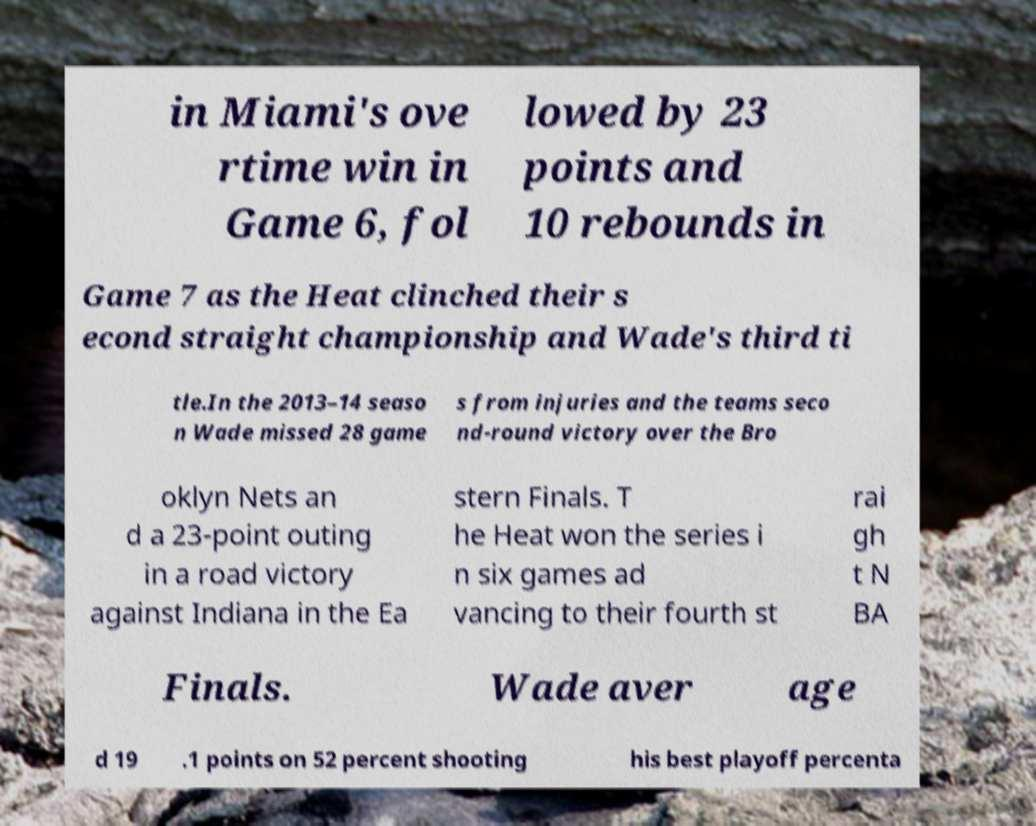Can you accurately transcribe the text from the provided image for me? in Miami's ove rtime win in Game 6, fol lowed by 23 points and 10 rebounds in Game 7 as the Heat clinched their s econd straight championship and Wade's third ti tle.In the 2013–14 seaso n Wade missed 28 game s from injuries and the teams seco nd-round victory over the Bro oklyn Nets an d a 23-point outing in a road victory against Indiana in the Ea stern Finals. T he Heat won the series i n six games ad vancing to their fourth st rai gh t N BA Finals. Wade aver age d 19 .1 points on 52 percent shooting his best playoff percenta 